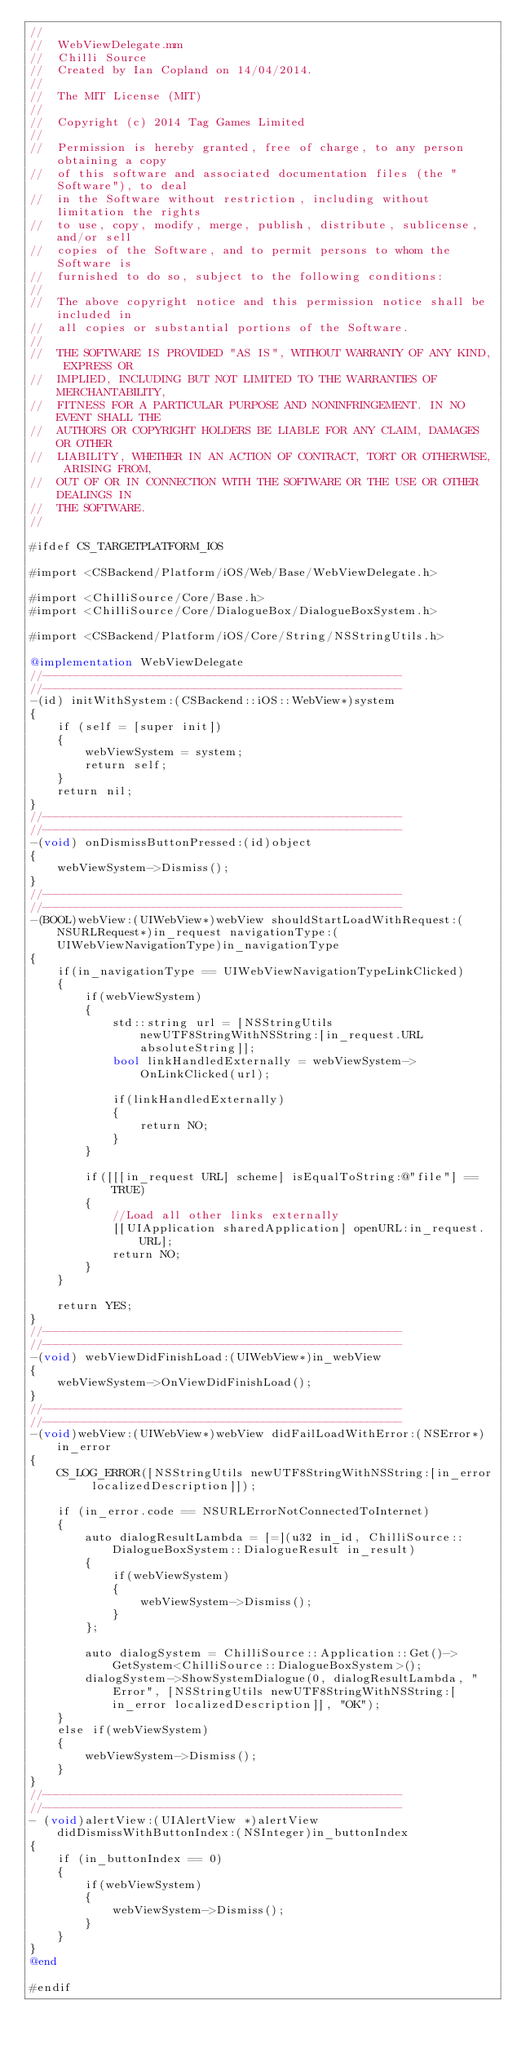<code> <loc_0><loc_0><loc_500><loc_500><_ObjectiveC_>//
//  WebViewDelegate.mm
//  Chilli Source
//  Created by Ian Copland on 14/04/2014.
//
//  The MIT License (MIT)
//
//  Copyright (c) 2014 Tag Games Limited
//
//  Permission is hereby granted, free of charge, to any person obtaining a copy
//  of this software and associated documentation files (the "Software"), to deal
//  in the Software without restriction, including without limitation the rights
//  to use, copy, modify, merge, publish, distribute, sublicense, and/or sell
//  copies of the Software, and to permit persons to whom the Software is
//  furnished to do so, subject to the following conditions:
//
//  The above copyright notice and this permission notice shall be included in
//  all copies or substantial portions of the Software.
//
//  THE SOFTWARE IS PROVIDED "AS IS", WITHOUT WARRANTY OF ANY KIND, EXPRESS OR
//  IMPLIED, INCLUDING BUT NOT LIMITED TO THE WARRANTIES OF MERCHANTABILITY,
//  FITNESS FOR A PARTICULAR PURPOSE AND NONINFRINGEMENT. IN NO EVENT SHALL THE
//  AUTHORS OR COPYRIGHT HOLDERS BE LIABLE FOR ANY CLAIM, DAMAGES OR OTHER
//  LIABILITY, WHETHER IN AN ACTION OF CONTRACT, TORT OR OTHERWISE, ARISING FROM,
//  OUT OF OR IN CONNECTION WITH THE SOFTWARE OR THE USE OR OTHER DEALINGS IN
//  THE SOFTWARE.
//

#ifdef CS_TARGETPLATFORM_IOS

#import <CSBackend/Platform/iOS/Web/Base/WebViewDelegate.h>

#import <ChilliSource/Core/Base.h>
#import <ChilliSource/Core/DialogueBox/DialogueBoxSystem.h>

#import <CSBackend/Platform/iOS/Core/String/NSStringUtils.h>

@implementation WebViewDelegate
//----------------------------------------------------
//----------------------------------------------------
-(id) initWithSystem:(CSBackend::iOS::WebView*)system
{
    if (self = [super init])
    {
        webViewSystem = system;
        return self;
    }
    return nil;
}
//----------------------------------------------------
//----------------------------------------------------
-(void) onDismissButtonPressed:(id)object
{
    webViewSystem->Dismiss();
}
//----------------------------------------------------
//----------------------------------------------------
-(BOOL)webView:(UIWebView*)webView shouldStartLoadWithRequest:(NSURLRequest*)in_request navigationType:(UIWebViewNavigationType)in_navigationType
{
    if(in_navigationType == UIWebViewNavigationTypeLinkClicked)
    {
        if(webViewSystem)
        {
            std::string url = [NSStringUtils newUTF8StringWithNSString:[in_request.URL absoluteString]];
            bool linkHandledExternally = webViewSystem->OnLinkClicked(url);
            
            if(linkHandledExternally)
            {
                return NO;
            }
        }
        
        if([[[in_request URL] scheme] isEqualToString:@"file"] == TRUE)
        {
            //Load all other links externally
            [[UIApplication sharedApplication] openURL:in_request.URL];
            return NO;
        }
    }
    
    return YES;
}
//----------------------------------------------------
//----------------------------------------------------
-(void) webViewDidFinishLoad:(UIWebView*)in_webView
{
    webViewSystem->OnViewDidFinishLoad();
}
//----------------------------------------------------
//----------------------------------------------------
-(void)webView:(UIWebView*)webView didFailLoadWithError:(NSError*)in_error
{
    CS_LOG_ERROR([NSStringUtils newUTF8StringWithNSString:[in_error localizedDescription]]);
    
    if (in_error.code == NSURLErrorNotConnectedToInternet)
    {
        auto dialogResultLambda = [=](u32 in_id, ChilliSource::DialogueBoxSystem::DialogueResult in_result)
        {
            if(webViewSystem)
            {
                webViewSystem->Dismiss();
            }
        };
        
        auto dialogSystem = ChilliSource::Application::Get()->GetSystem<ChilliSource::DialogueBoxSystem>();
        dialogSystem->ShowSystemDialogue(0, dialogResultLambda, "Error", [NSStringUtils newUTF8StringWithNSString:[in_error localizedDescription]], "OK");
    }
    else if(webViewSystem)
    {
        webViewSystem->Dismiss();
    }
}
//----------------------------------------------------
//----------------------------------------------------
- (void)alertView:(UIAlertView *)alertView didDismissWithButtonIndex:(NSInteger)in_buttonIndex
{
    if (in_buttonIndex == 0)
    {
        if(webViewSystem)
        {
            webViewSystem->Dismiss();
        }
    }
}
@end

#endif</code> 